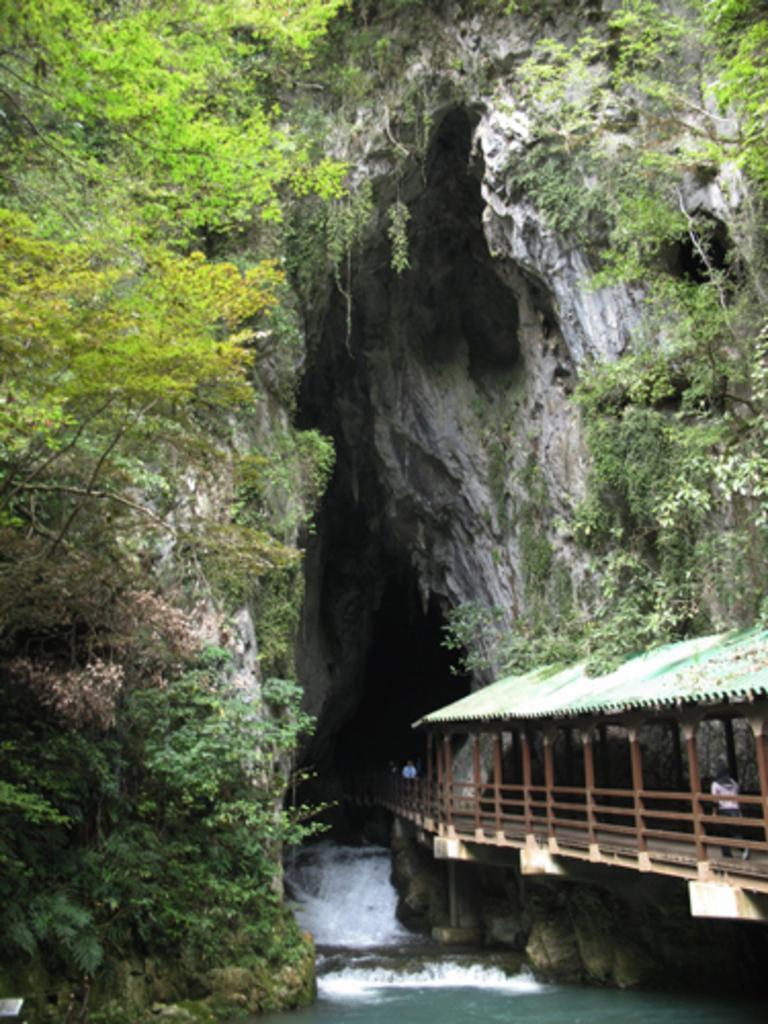Describe this image in one or two sentences. This image is taken outdoors. At the bottom of the image there is a lake with water. On the right side of the image there is a hut and there are a few trees. In the middle of the image there is a big rock and there are a few trees and plants. 